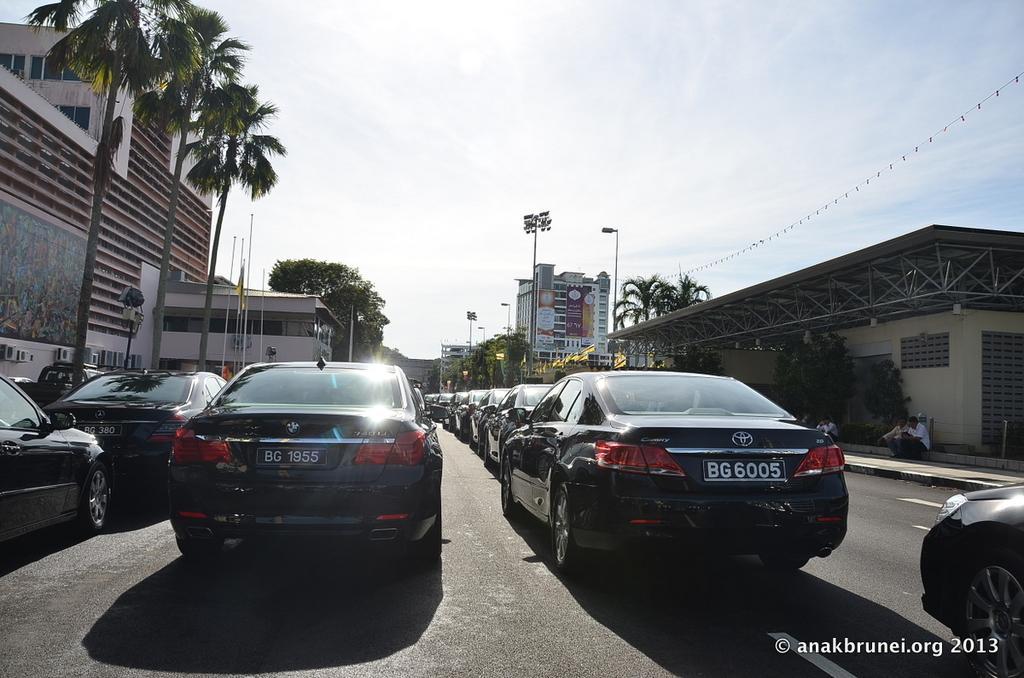Could you give a brief overview of what you see in this image? In this image there are buildings and trees on the left corner. There are building, trees, people and metal poles on the right corner. There is a road at the bottom. There are vehicles in the foreground. And there is sky at the top. 